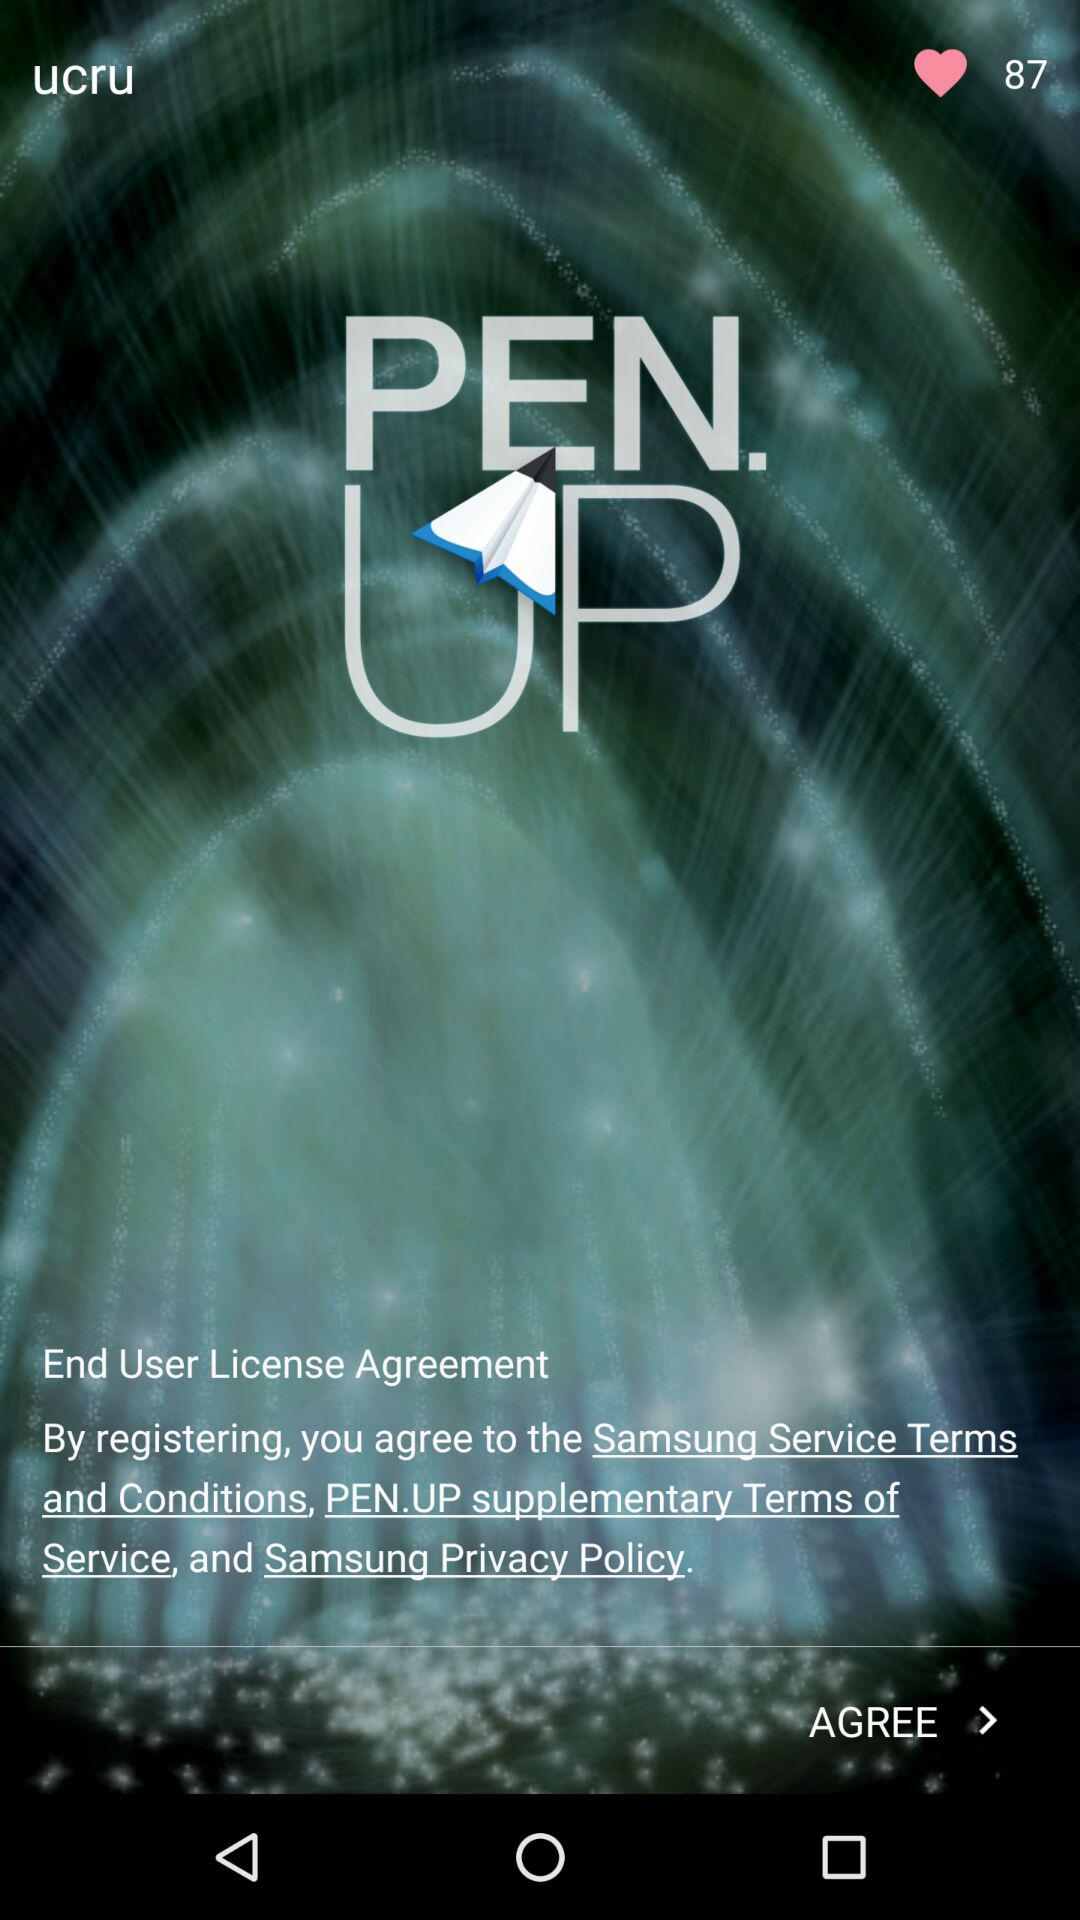What is the name of the application? The name of the application is "PEN.UP". 